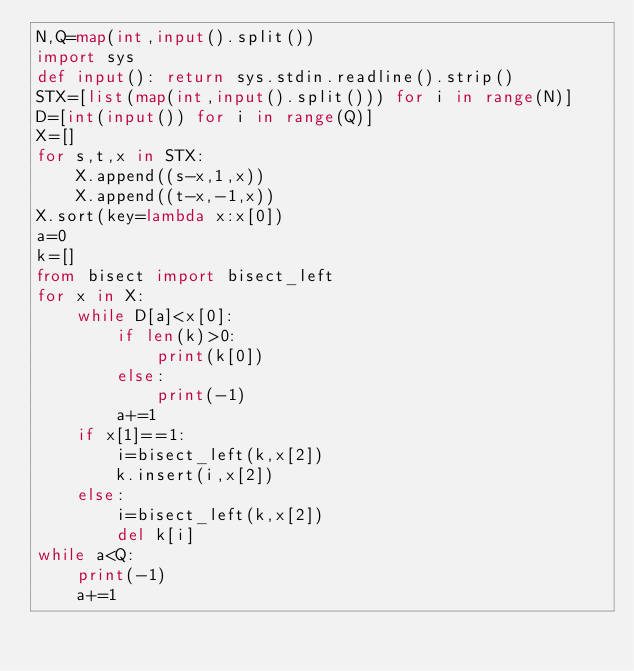<code> <loc_0><loc_0><loc_500><loc_500><_Python_>N,Q=map(int,input().split())
import sys
def input(): return sys.stdin.readline().strip()
STX=[list(map(int,input().split())) for i in range(N)]
D=[int(input()) for i in range(Q)]
X=[]
for s,t,x in STX:
    X.append((s-x,1,x))
    X.append((t-x,-1,x))
X.sort(key=lambda x:x[0])
a=0
k=[]
from bisect import bisect_left
for x in X:
    while D[a]<x[0]:
        if len(k)>0:
            print(k[0])
        else:
            print(-1)
        a+=1
    if x[1]==1:
        i=bisect_left(k,x[2])
        k.insert(i,x[2])
    else:
        i=bisect_left(k,x[2])
        del k[i]
while a<Q:
    print(-1)
    a+=1</code> 